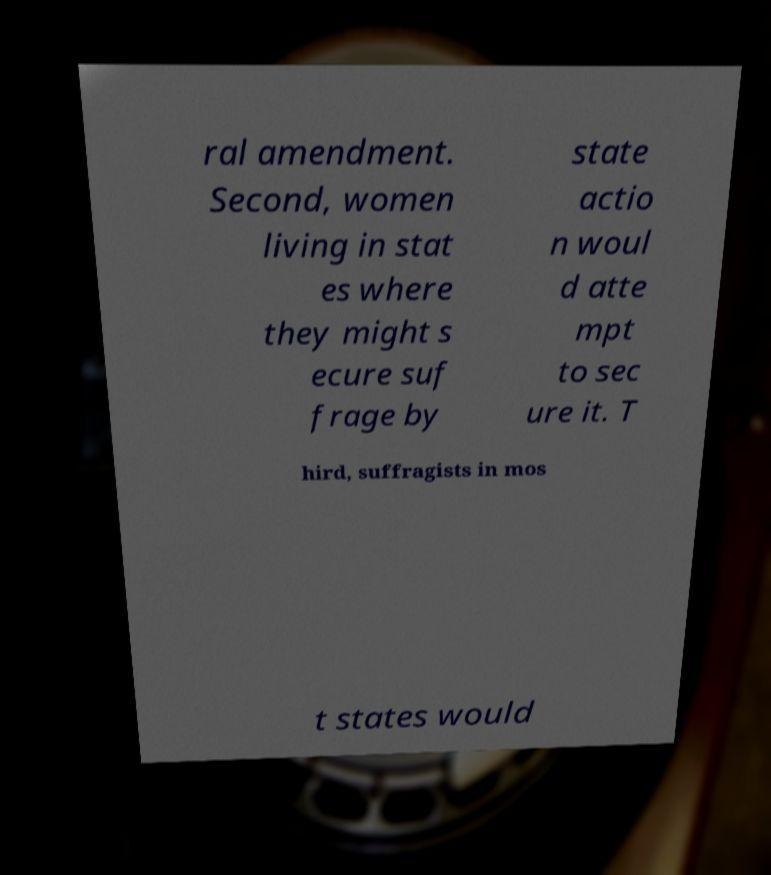Please identify and transcribe the text found in this image. ral amendment. Second, women living in stat es where they might s ecure suf frage by state actio n woul d atte mpt to sec ure it. T hird, suffragists in mos t states would 